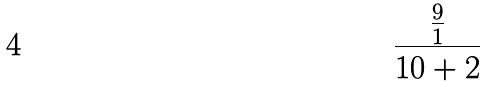Convert formula to latex. <formula><loc_0><loc_0><loc_500><loc_500>\frac { \frac { 9 } { 1 } } { 1 0 + 2 }</formula> 